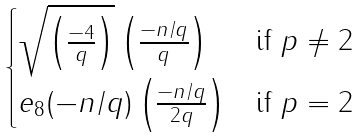Convert formula to latex. <formula><loc_0><loc_0><loc_500><loc_500>\begin{cases} \sqrt { \left ( \frac { - 4 } q \right ) } \left ( \frac { - n / q } q \right ) & \text {if } p \not = 2 \\ e _ { 8 } ( - n / q ) \left ( \frac { - n / q } { 2 q } \right ) & \text {if } p = 2 \end{cases}</formula> 